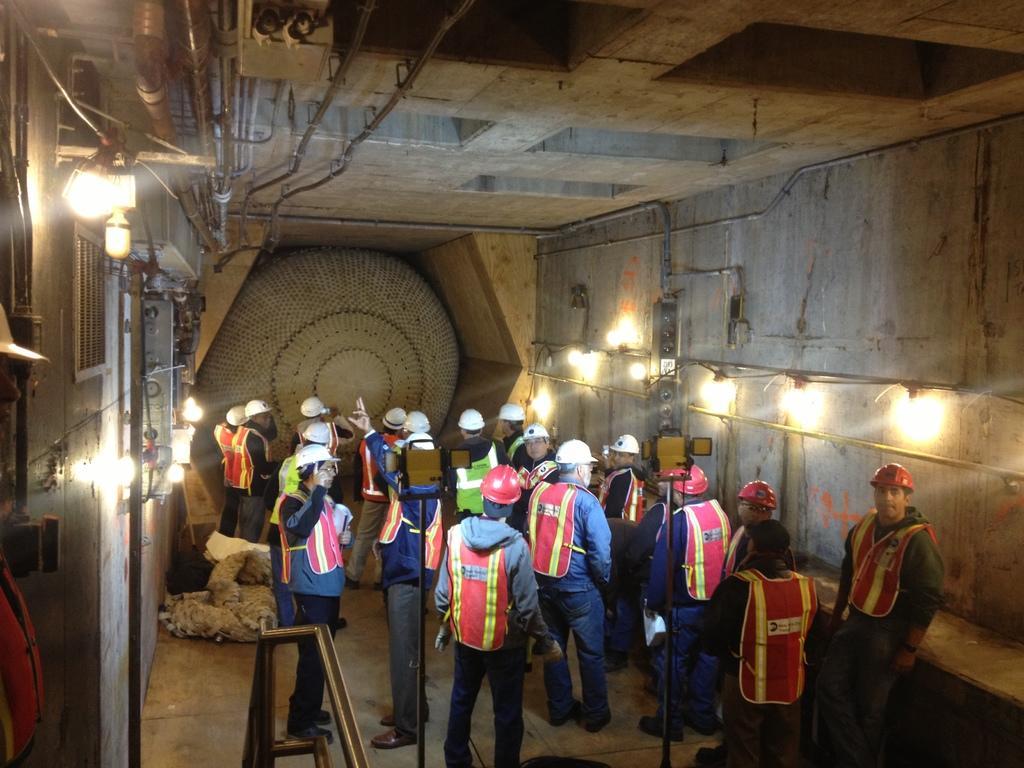How would you summarize this image in a sentence or two? This picture is clicked inside the hall. In the foreground we can see the group of persons wearing helmets and standing and we can see the metal objects and some other objects are placed on the ground and we can see the lights. At the top there is a roof and some other objects. In the background we can see the wall and some other object. 